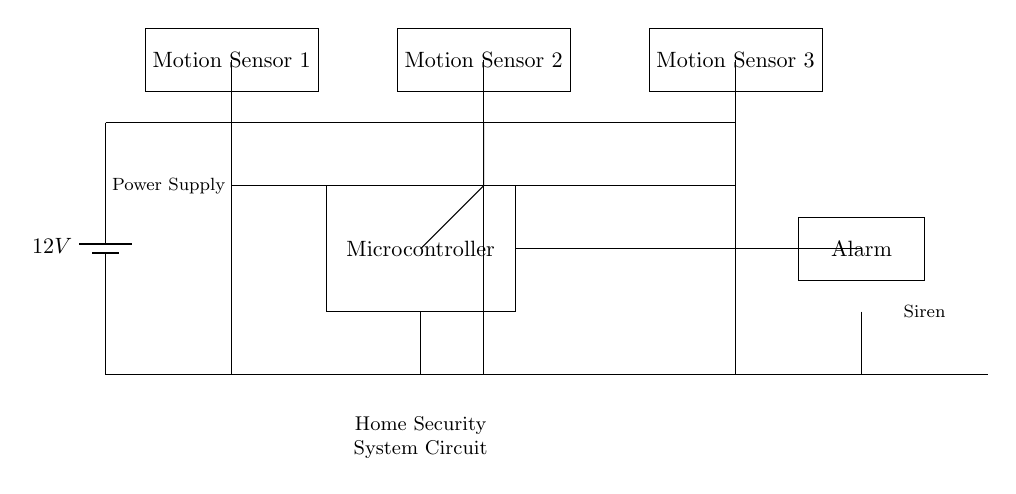What is the power supply voltage? The circuit shows a battery labeled with a voltage of 12V. This indicates the power supply voltage for the entire system.
Answer: 12V How many motion sensors are there? The diagram displays three motion sensors connected to the power supply, indicating the total count of these components.
Answer: Three What is the function of the microcontroller? The microcontroller in the circuit processes the signals received from the motion sensors and triggers the alarm based on their status.
Answer: Process signals What connects the motion sensors to the microcontroller? Each motion sensor is directly connected to the microcontroller through specific lines shown in the diagram, allowing for signal communication.
Answer: Wires What happens when a motion sensor detects motion? When a motion sensor detects motion, it sends a signal to the microcontroller, which then activates the alarm. This is an interdependent action highlighted in the diagram.
Answer: Alarm activation What is the relationship between the alarm and the microcontroller? The alarm is connected directly to the microcontroller, meaning that the controller sends a signal to trigger the alarm when necessary. This connection is visually represented in the circuit.
Answer: Direct connection 